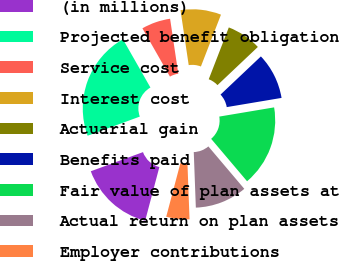<chart> <loc_0><loc_0><loc_500><loc_500><pie_chart><fcel>(in millions)<fcel>Projected benefit obligation<fcel>Service cost<fcel>Interest cost<fcel>Actuarial gain<fcel>Benefits paid<fcel>Fair value of plan assets at<fcel>Actual return on plan assets<fcel>Employer contributions<nl><fcel>15.29%<fcel>22.34%<fcel>5.89%<fcel>8.24%<fcel>7.06%<fcel>9.41%<fcel>16.46%<fcel>10.59%<fcel>4.71%<nl></chart> 